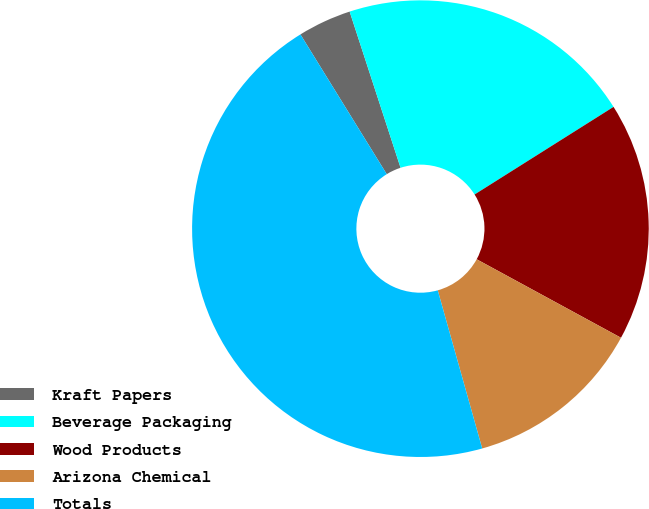Convert chart. <chart><loc_0><loc_0><loc_500><loc_500><pie_chart><fcel>Kraft Papers<fcel>Beverage Packaging<fcel>Wood Products<fcel>Arizona Chemical<fcel>Totals<nl><fcel>3.79%<fcel>21.06%<fcel>16.88%<fcel>12.71%<fcel>45.55%<nl></chart> 